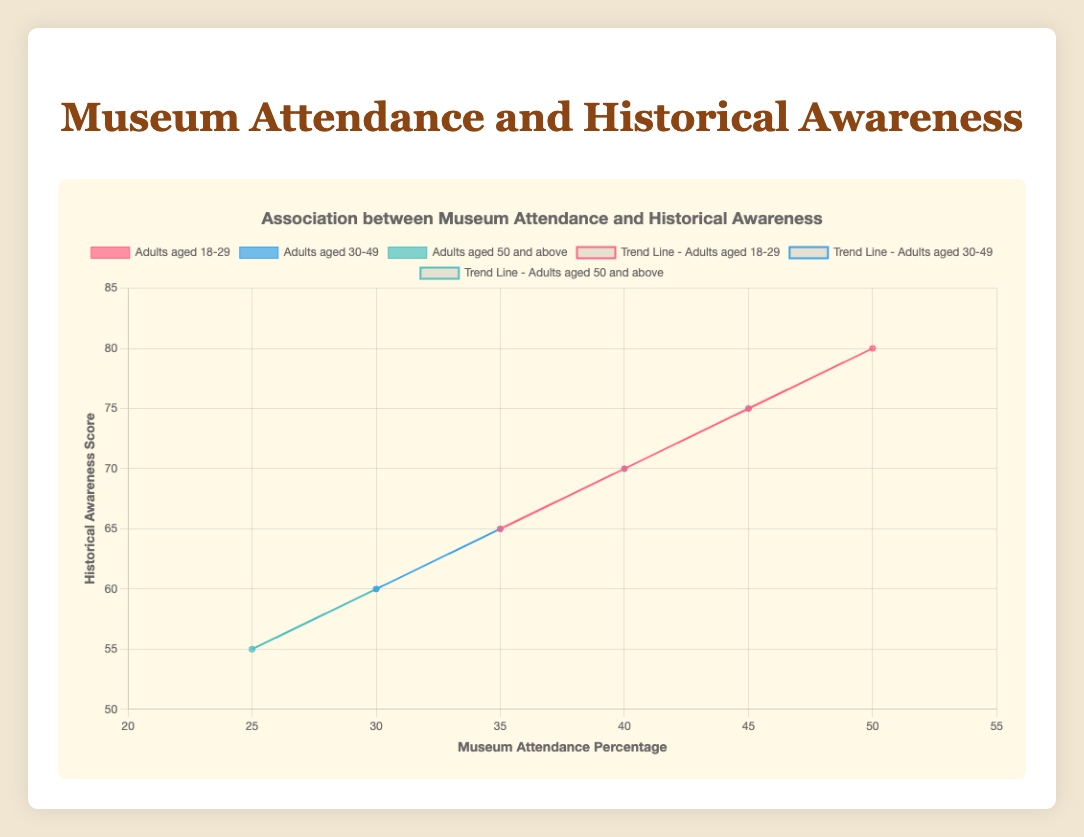What is the trend between museum attendance and historical awareness for the "Adults aged 18-29" group? The scatter plot shows data points for "Adults aged 18-29" in red, with a trend line indicating the trend. The line slopes upward, suggesting that as museum attendance percentage increases, the historical awareness score also increases.
Answer: Positive correlation How has the historical awareness score for "Adults aged 30-49" changed from 1990 to 2020? From the scatter plot, locate the data points for the years 1990 and 2020 for "Adults aged 30-49" shown in blue. In 1990, the score is 60, and in 2020, it is 75. This shows an increase of 15 points.
Answer: Increased by 15 points Which demographic group has the highest museum attendance percentage in 2020? Identify the year 2020 data points across all three groups. The group "Adults aged 18-29" has the highest attendance percentage at 50%.
Answer: Adults aged 18-29 Is there a difference in the trend lines' slopes among the three demographic groups? The scatter plot has trend lines for each group. Observing the steepness of each line, it is clear that the slopes are similar, indicating that the relationship between museum attendance and historical awareness is consistently positive across all groups.
Answer: No significant difference What is the historical awareness score for "Adults aged 50 and above" when their museum attendance is at 35%? Locate the data point for "Adults aged 50 and above" at 35% attendance (green dots). The score is indicated as 65.
Answer: 65 How does the historical awareness score for "Adults aged 30-49" compare to "Adults aged 50 and above" at 30% museum attendance? Examine the data points at 30% attendance for both groups. "Adults aged 30-49" show a score of 65, while "Adults aged 50 and above" have a score of 60. "Adults aged 30-49" have a higher score by 5 points.
Answer: Higher by 5 points What can you infer about the relationship between museum attendance and historical awareness from the overall pattern of the scatter plot? The pattern shows a positive correlation for each demographic group, as indicated by the upward trend lines. This suggests that higher museum attendance is associated with higher historical awareness.
Answer: Positive correlation Is there any group where an increase in museum attendance does not significantly increase historical awareness? Evaluate the trend lines' steepness for each group. All groups exhibit a positive slope, indicating that an increase in museum attendance always leads to a significant rise in historical awareness across the groups.
Answer: No How many data points are presented in total for each demographic group over the last three decades? Each decade (1990, 2000, 2010, 2020) has one data point per group, making it 4 data points per group. There are three groups, so it sums up to 12 data points in total.
Answer: 12 What is the museum attendance percentage range for "Adults aged 30-49"? Analyze the data points for "Adults aged 30-49". The range starts at 30% in 1990 and ends at 45% in 2020.
Answer: 30% to 45% 